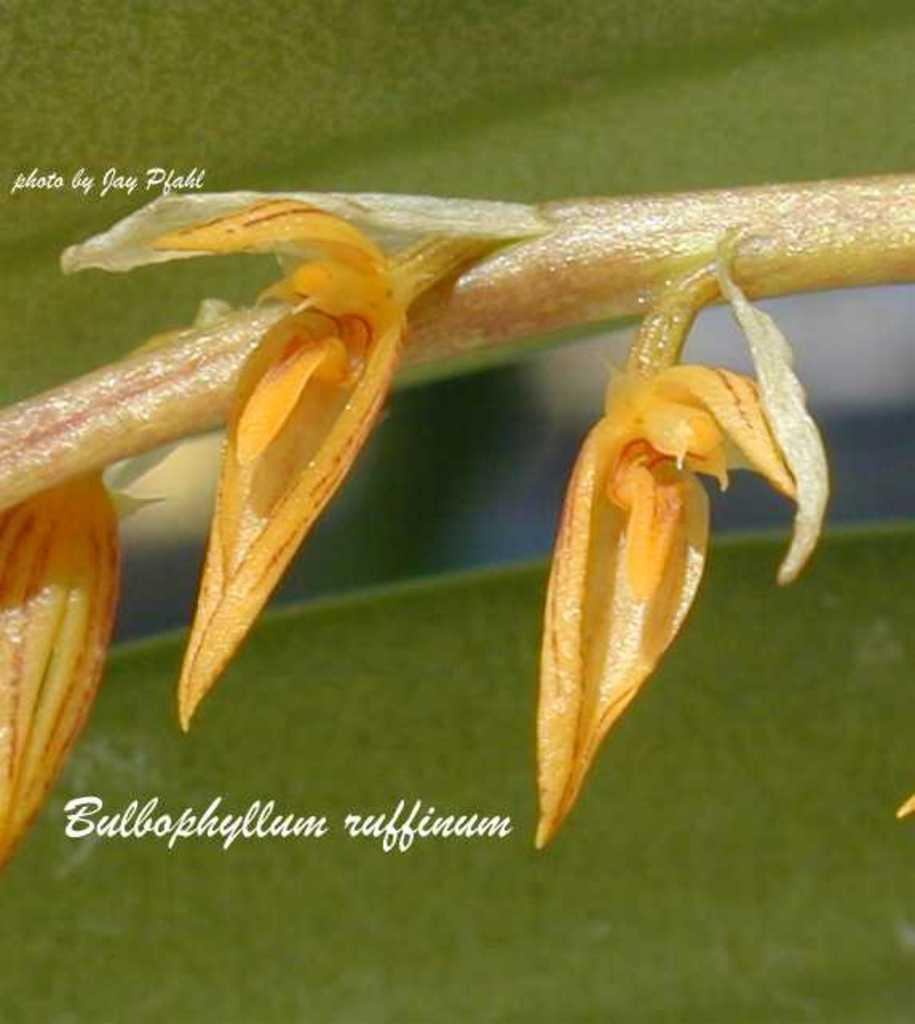What type of plant is depicted in the image? There are leaves on a stem in the image, which suggests a plant. Can you describe any other elements in the image? Yes, there is text in the image. What type of drum can be seen in the image? There is no drum present in the image. What time of day is it in the image? The time of day is not indicated in the image. 